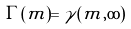Convert formula to latex. <formula><loc_0><loc_0><loc_500><loc_500>\Gamma ( m ) = \gamma ( m , \infty )</formula> 